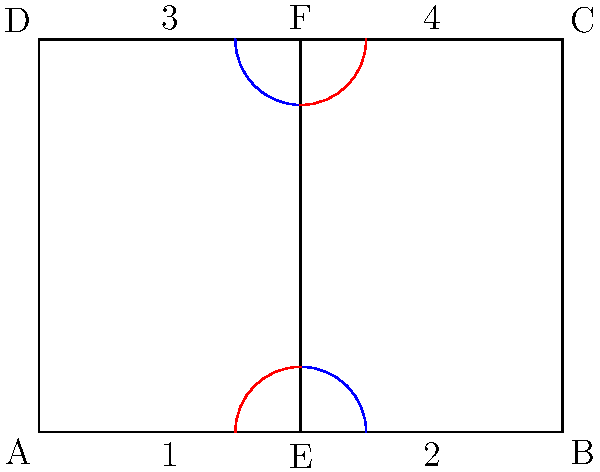A folding walker design is shown above. The walker can be folded by rotating the left and right sides towards the center. Which of the following pairs of angles are congruent when the walker is partially folded? To determine which pairs of angles are congruent, let's analyze the folding mechanism of the walker:

1. The walker is symmetrical, with a vertical line of symmetry running through the center (line EF).

2. When folding, the left and right sides of the walker rotate towards the center line EF.

3. The blue arcs at points E and F represent angles formed by the bottom bar (AB) and the center line (EF) on both sides.

4. The red arcs at points E and F represent angles formed by the center line (EF) and the side bars (AD and BC) on both sides.

5. Due to the symmetry of the walker and the folding mechanism:
   a) The angle represented by the blue arc at E is congruent to the angle represented by the blue arc at F.
   b) The angle represented by the red arc at E is congruent to the angle represented by the red arc at F.

6. These congruences hold true regardless of how much the walker is folded, as long as both sides are folded equally.

Therefore, the congruent pairs of angles are:
- The two angles represented by the blue arcs
- The two angles represented by the red arcs
Answer: Blue angles at E and F; Red angles at E and F 